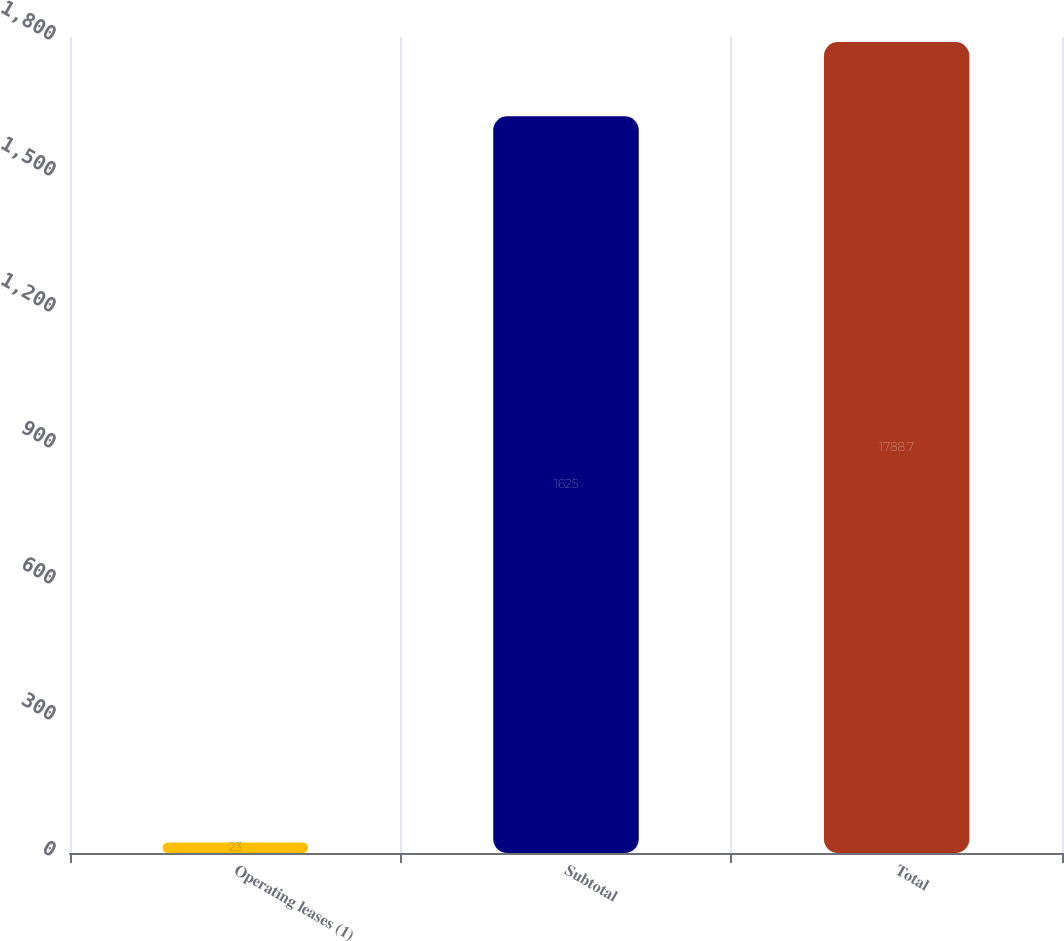Convert chart to OTSL. <chart><loc_0><loc_0><loc_500><loc_500><bar_chart><fcel>Operating leases (1)<fcel>Subtotal<fcel>Total<nl><fcel>23<fcel>1625<fcel>1788.7<nl></chart> 